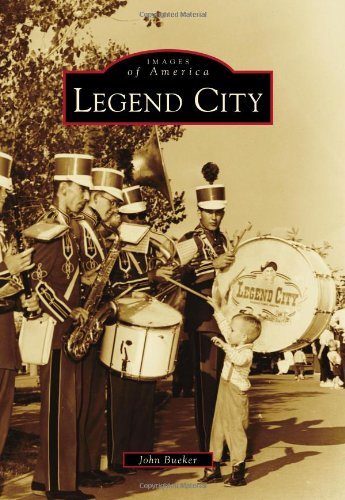Describe the visual style and elements seen in this image. The image is styled in a nostalgic, black-and-white format, capturing a moment that emphasizes the cultural importance of music and community events in public spaces during that era. The details such as uniforms, instruments, and the earnest expression of the child, all contribute to a lively portrayal. 